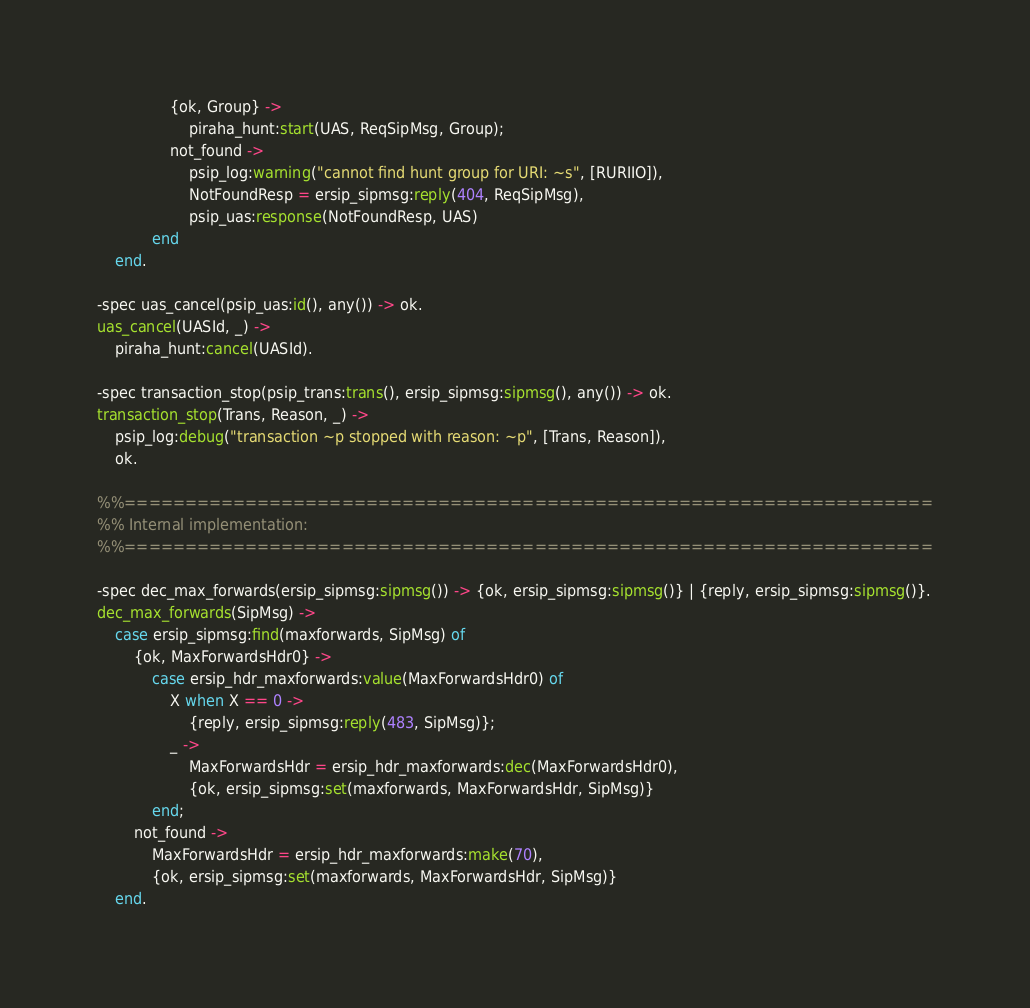<code> <loc_0><loc_0><loc_500><loc_500><_Erlang_>                {ok, Group} ->
                    piraha_hunt:start(UAS, ReqSipMsg, Group);
                not_found ->
                    psip_log:warning("cannot find hunt group for URI: ~s", [RURIIO]),
                    NotFoundResp = ersip_sipmsg:reply(404, ReqSipMsg),
                    psip_uas:response(NotFoundResp, UAS)
            end
    end.

-spec uas_cancel(psip_uas:id(), any()) -> ok.
uas_cancel(UASId, _) ->
    piraha_hunt:cancel(UASId).

-spec transaction_stop(psip_trans:trans(), ersip_sipmsg:sipmsg(), any()) -> ok.
transaction_stop(Trans, Reason, _) ->
    psip_log:debug("transaction ~p stopped with reason: ~p", [Trans, Reason]),
    ok.

%%===================================================================
%% Internal implementation:
%%===================================================================

-spec dec_max_forwards(ersip_sipmsg:sipmsg()) -> {ok, ersip_sipmsg:sipmsg()} | {reply, ersip_sipmsg:sipmsg()}.
dec_max_forwards(SipMsg) ->
    case ersip_sipmsg:find(maxforwards, SipMsg) of
        {ok, MaxForwardsHdr0} ->
            case ersip_hdr_maxforwards:value(MaxForwardsHdr0) of
                X when X == 0 ->
                    {reply, ersip_sipmsg:reply(483, SipMsg)};
                _ ->
                    MaxForwardsHdr = ersip_hdr_maxforwards:dec(MaxForwardsHdr0),
                    {ok, ersip_sipmsg:set(maxforwards, MaxForwardsHdr, SipMsg)}
            end;
        not_found ->
            MaxForwardsHdr = ersip_hdr_maxforwards:make(70),
            {ok, ersip_sipmsg:set(maxforwards, MaxForwardsHdr, SipMsg)}
    end.
</code> 